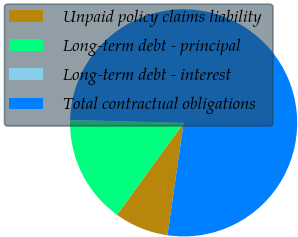Convert chart to OTSL. <chart><loc_0><loc_0><loc_500><loc_500><pie_chart><fcel>Unpaid policy claims liability<fcel>Long-term debt - principal<fcel>Long-term debt - interest<fcel>Total contractual obligations<nl><fcel>7.71%<fcel>15.4%<fcel>0.03%<fcel>76.86%<nl></chart> 